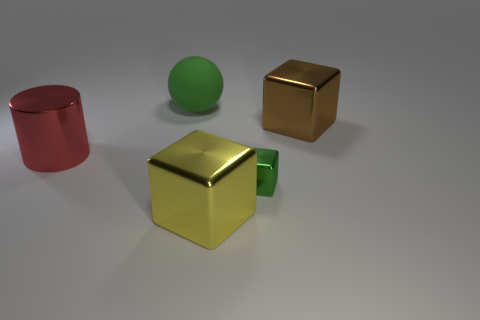Add 3 green shiny cubes. How many objects exist? 8 Subtract all brown metallic blocks. How many blocks are left? 2 Subtract 0 yellow cylinders. How many objects are left? 5 Subtract all cubes. How many objects are left? 2 Subtract 1 balls. How many balls are left? 0 Subtract all gray balls. Subtract all blue cylinders. How many balls are left? 1 Subtract all blue blocks. How many brown cylinders are left? 0 Subtract all brown shiny things. Subtract all tiny red matte objects. How many objects are left? 4 Add 2 large shiny cylinders. How many large shiny cylinders are left? 3 Add 2 small gray blocks. How many small gray blocks exist? 2 